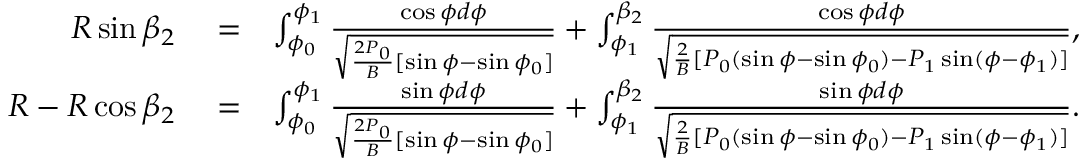Convert formula to latex. <formula><loc_0><loc_0><loc_500><loc_500>\begin{array} { r l r } { R \sin \beta _ { 2 } } & = } & { \int _ { \phi _ { 0 } } ^ { \phi _ { 1 } } \frac { \cos \phi d \phi } { \sqrt { \frac { 2 P _ { 0 } } { B } [ \sin \phi - \sin \phi _ { 0 } ] } } + \int _ { \phi _ { 1 } } ^ { \beta _ { 2 } } \frac { \cos \phi d \phi } { \sqrt { \frac { 2 } { B } [ P _ { 0 } ( \sin \phi - \sin \phi _ { 0 } ) - P _ { 1 } \sin ( \phi - \phi _ { 1 } ) ] } } , } \\ { R - R \cos \beta _ { 2 } } & = } & { \int _ { \phi _ { 0 } } ^ { \phi _ { 1 } } \frac { \sin \phi d \phi } { \sqrt { \frac { 2 P _ { 0 } } { B } [ \sin \phi - \sin \phi _ { 0 } ] } } + \int _ { \phi _ { 1 } } ^ { \beta _ { 2 } } \frac { \sin \phi d \phi } { \sqrt { \frac { 2 } { B } [ P _ { 0 } ( \sin \phi - \sin \phi _ { 0 } ) - P _ { 1 } \sin ( \phi - \phi _ { 1 } ) ] } } . } \end{array}</formula> 